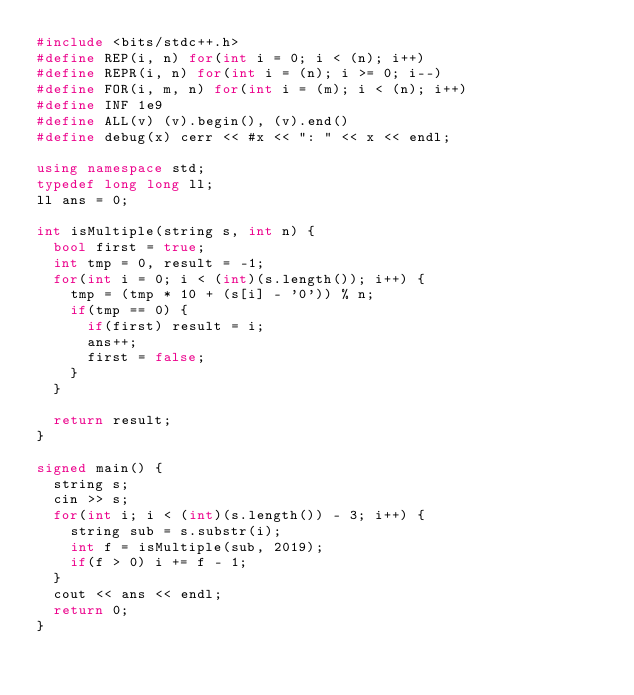<code> <loc_0><loc_0><loc_500><loc_500><_C++_>#include <bits/stdc++.h>
#define REP(i, n) for(int i = 0; i < (n); i++)
#define REPR(i, n) for(int i = (n); i >= 0; i--)
#define FOR(i, m, n) for(int i = (m); i < (n); i++)
#define INF 1e9
#define ALL(v) (v).begin(), (v).end()
#define debug(x) cerr << #x << ": " << x << endl;

using namespace std;
typedef long long ll;
ll ans = 0;

int isMultiple(string s, int n) {
  bool first = true;
  int tmp = 0, result = -1;
  for(int i = 0; i < (int)(s.length()); i++) {
    tmp = (tmp * 10 + (s[i] - '0')) % n;
    if(tmp == 0) {
      if(first) result = i;
      ans++;
      first = false;
    }
  }

  return result;
}

signed main() {
  string s;
  cin >> s;
  for(int i; i < (int)(s.length()) - 3; i++) {
    string sub = s.substr(i);
    int f = isMultiple(sub, 2019);
    if(f > 0) i += f - 1;
  }
  cout << ans << endl;
  return 0;
}
</code> 